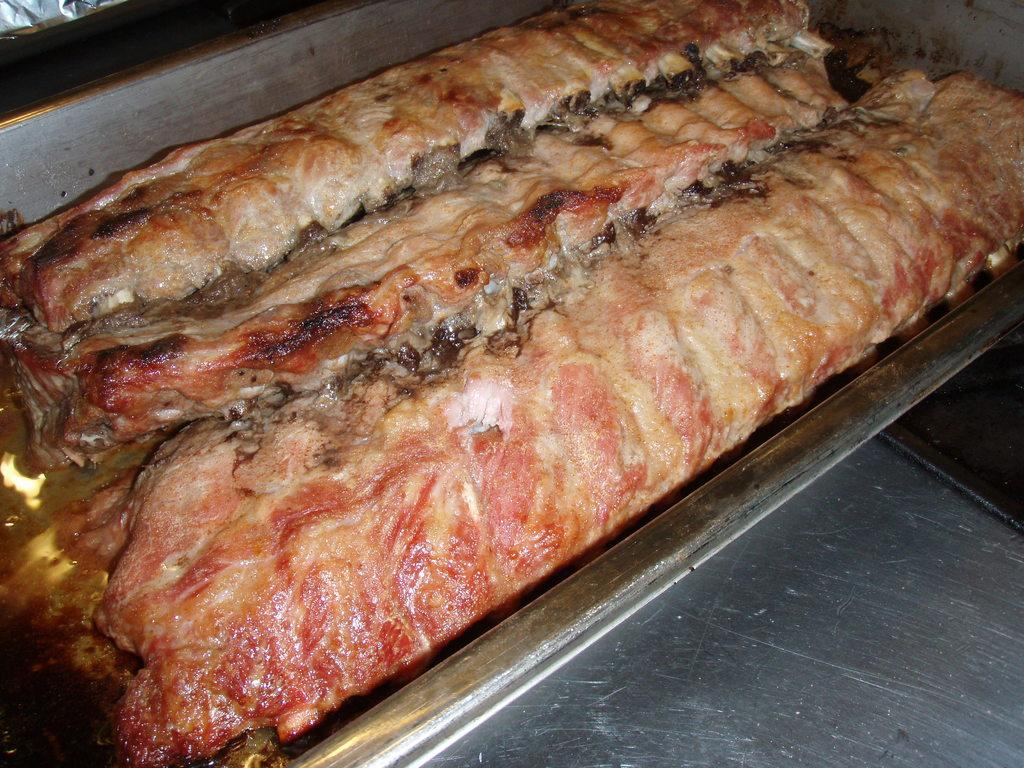What is present in the image? There is food in the image. How is the food contained or stored? The food is in a steel container. Can you see a bee jumping over the food in the image? There is no bee or jumping action present in the image; it only shows food in a steel container. 